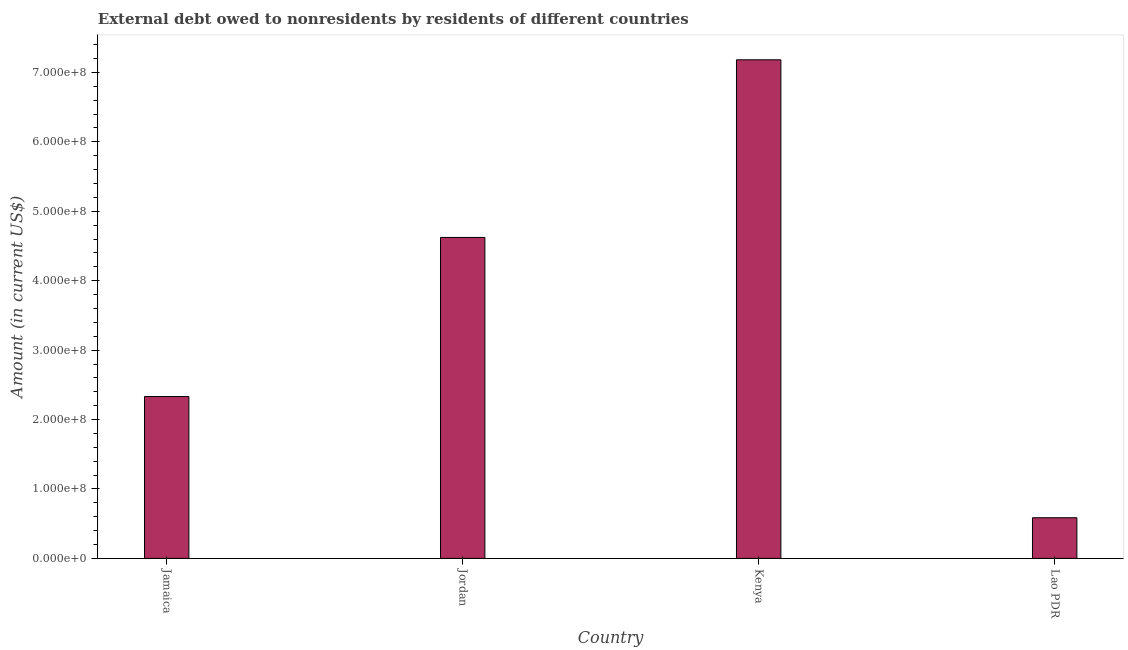Does the graph contain any zero values?
Your response must be concise. No. Does the graph contain grids?
Your answer should be very brief. No. What is the title of the graph?
Ensure brevity in your answer.  External debt owed to nonresidents by residents of different countries. What is the label or title of the Y-axis?
Keep it short and to the point. Amount (in current US$). What is the debt in Kenya?
Provide a short and direct response. 7.18e+08. Across all countries, what is the maximum debt?
Your answer should be very brief. 7.18e+08. Across all countries, what is the minimum debt?
Your answer should be very brief. 5.86e+07. In which country was the debt maximum?
Provide a succinct answer. Kenya. In which country was the debt minimum?
Your answer should be very brief. Lao PDR. What is the sum of the debt?
Offer a terse response. 1.47e+09. What is the difference between the debt in Jamaica and Jordan?
Your answer should be compact. -2.29e+08. What is the average debt per country?
Your answer should be compact. 3.68e+08. What is the median debt?
Provide a short and direct response. 3.48e+08. In how many countries, is the debt greater than 280000000 US$?
Your answer should be very brief. 2. What is the ratio of the debt in Jordan to that in Kenya?
Your answer should be compact. 0.64. Is the debt in Jamaica less than that in Kenya?
Provide a succinct answer. Yes. What is the difference between the highest and the second highest debt?
Give a very brief answer. 2.56e+08. What is the difference between the highest and the lowest debt?
Your answer should be very brief. 6.60e+08. In how many countries, is the debt greater than the average debt taken over all countries?
Give a very brief answer. 2. Are all the bars in the graph horizontal?
Your answer should be very brief. No. Are the values on the major ticks of Y-axis written in scientific E-notation?
Give a very brief answer. Yes. What is the Amount (in current US$) of Jamaica?
Make the answer very short. 2.33e+08. What is the Amount (in current US$) of Jordan?
Provide a succinct answer. 4.62e+08. What is the Amount (in current US$) of Kenya?
Make the answer very short. 7.18e+08. What is the Amount (in current US$) in Lao PDR?
Provide a succinct answer. 5.86e+07. What is the difference between the Amount (in current US$) in Jamaica and Jordan?
Give a very brief answer. -2.29e+08. What is the difference between the Amount (in current US$) in Jamaica and Kenya?
Ensure brevity in your answer.  -4.85e+08. What is the difference between the Amount (in current US$) in Jamaica and Lao PDR?
Give a very brief answer. 1.75e+08. What is the difference between the Amount (in current US$) in Jordan and Kenya?
Give a very brief answer. -2.56e+08. What is the difference between the Amount (in current US$) in Jordan and Lao PDR?
Offer a terse response. 4.04e+08. What is the difference between the Amount (in current US$) in Kenya and Lao PDR?
Your answer should be very brief. 6.60e+08. What is the ratio of the Amount (in current US$) in Jamaica to that in Jordan?
Ensure brevity in your answer.  0.5. What is the ratio of the Amount (in current US$) in Jamaica to that in Kenya?
Offer a very short reply. 0.33. What is the ratio of the Amount (in current US$) in Jamaica to that in Lao PDR?
Provide a succinct answer. 3.98. What is the ratio of the Amount (in current US$) in Jordan to that in Kenya?
Give a very brief answer. 0.64. What is the ratio of the Amount (in current US$) in Jordan to that in Lao PDR?
Your answer should be very brief. 7.89. What is the ratio of the Amount (in current US$) in Kenya to that in Lao PDR?
Make the answer very short. 12.27. 